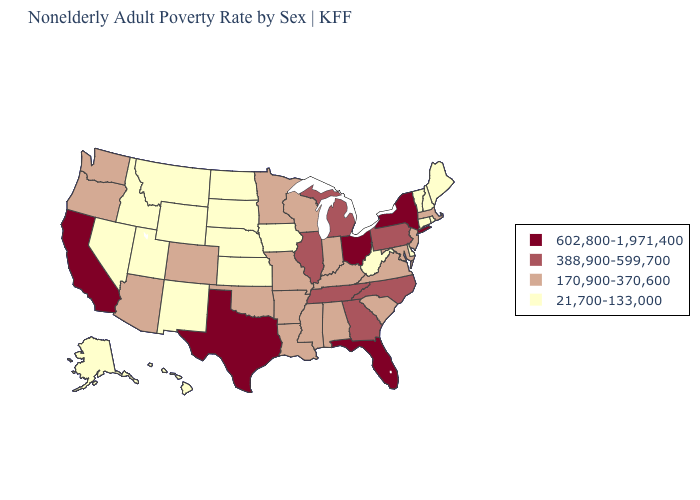What is the lowest value in states that border Idaho?
Give a very brief answer. 21,700-133,000. What is the value of Pennsylvania?
Answer briefly. 388,900-599,700. How many symbols are there in the legend?
Write a very short answer. 4. Does the map have missing data?
Write a very short answer. No. What is the highest value in states that border Wisconsin?
Concise answer only. 388,900-599,700. What is the value of New Mexico?
Keep it brief. 21,700-133,000. What is the highest value in states that border Kansas?
Give a very brief answer. 170,900-370,600. What is the highest value in the USA?
Be succinct. 602,800-1,971,400. Among the states that border Maryland , which have the highest value?
Quick response, please. Pennsylvania. What is the value of South Dakota?
Answer briefly. 21,700-133,000. What is the lowest value in states that border Delaware?
Short answer required. 170,900-370,600. What is the value of New Jersey?
Short answer required. 170,900-370,600. Does Massachusetts have the lowest value in the Northeast?
Write a very short answer. No. What is the value of Mississippi?
Concise answer only. 170,900-370,600. Which states have the highest value in the USA?
Keep it brief. California, Florida, New York, Ohio, Texas. 